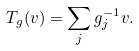<formula> <loc_0><loc_0><loc_500><loc_500>T _ { g } ( v ) = \sum _ { j } g _ { j } ^ { - 1 } v .</formula> 